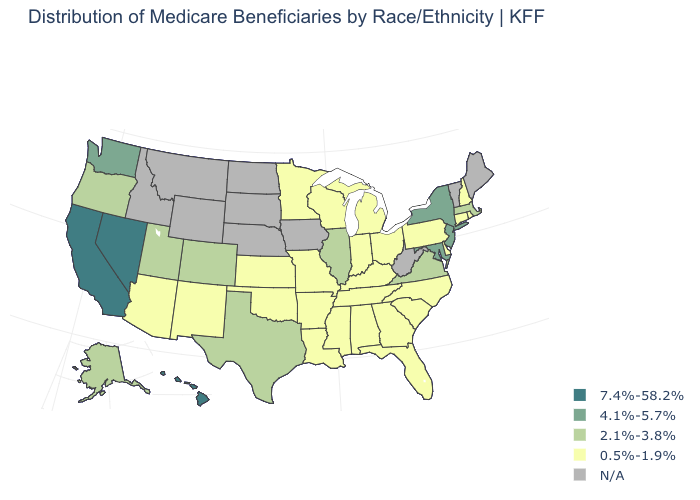Name the states that have a value in the range 0.5%-1.9%?
Quick response, please. Alabama, Arizona, Arkansas, Connecticut, Delaware, Florida, Georgia, Indiana, Kansas, Kentucky, Louisiana, Michigan, Minnesota, Mississippi, Missouri, New Hampshire, New Mexico, North Carolina, Ohio, Oklahoma, Pennsylvania, Rhode Island, South Carolina, Tennessee, Wisconsin. What is the value of Nevada?
Be succinct. 7.4%-58.2%. Which states have the lowest value in the USA?
Be succinct. Alabama, Arizona, Arkansas, Connecticut, Delaware, Florida, Georgia, Indiana, Kansas, Kentucky, Louisiana, Michigan, Minnesota, Mississippi, Missouri, New Hampshire, New Mexico, North Carolina, Ohio, Oklahoma, Pennsylvania, Rhode Island, South Carolina, Tennessee, Wisconsin. Does the first symbol in the legend represent the smallest category?
Write a very short answer. No. Among the states that border New Hampshire , which have the lowest value?
Concise answer only. Massachusetts. Name the states that have a value in the range 7.4%-58.2%?
Answer briefly. California, Hawaii, Nevada. Does the map have missing data?
Keep it brief. Yes. Name the states that have a value in the range 2.1%-3.8%?
Keep it brief. Alaska, Colorado, Illinois, Massachusetts, Oregon, Texas, Utah, Virginia. What is the value of Colorado?
Quick response, please. 2.1%-3.8%. What is the value of Alaska?
Concise answer only. 2.1%-3.8%. What is the highest value in states that border Iowa?
Be succinct. 2.1%-3.8%. Which states hav the highest value in the West?
Short answer required. California, Hawaii, Nevada. What is the value of Florida?
Keep it brief. 0.5%-1.9%. What is the value of North Carolina?
Short answer required. 0.5%-1.9%. 